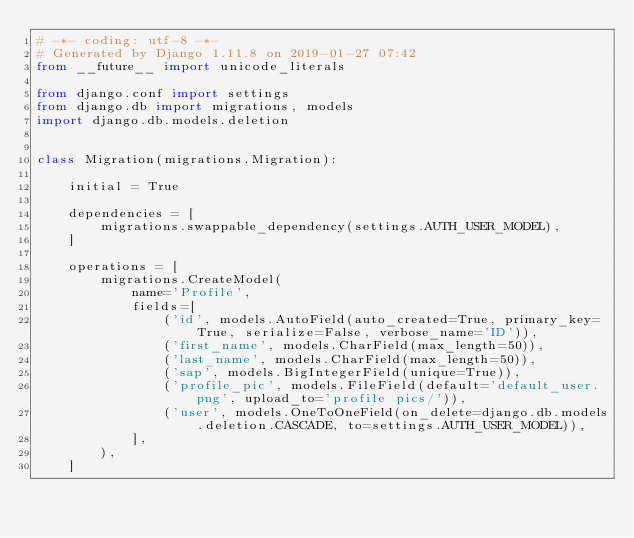<code> <loc_0><loc_0><loc_500><loc_500><_Python_># -*- coding: utf-8 -*-
# Generated by Django 1.11.8 on 2019-01-27 07:42
from __future__ import unicode_literals

from django.conf import settings
from django.db import migrations, models
import django.db.models.deletion


class Migration(migrations.Migration):

    initial = True

    dependencies = [
        migrations.swappable_dependency(settings.AUTH_USER_MODEL),
    ]

    operations = [
        migrations.CreateModel(
            name='Profile',
            fields=[
                ('id', models.AutoField(auto_created=True, primary_key=True, serialize=False, verbose_name='ID')),
                ('first_name', models.CharField(max_length=50)),
                ('last_name', models.CharField(max_length=50)),
                ('sap', models.BigIntegerField(unique=True)),
                ('profile_pic', models.FileField(default='default_user.png', upload_to='profile pics/')),
                ('user', models.OneToOneField(on_delete=django.db.models.deletion.CASCADE, to=settings.AUTH_USER_MODEL)),
            ],
        ),
    ]
</code> 